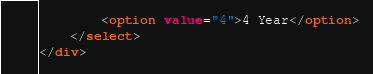Convert code to text. <code><loc_0><loc_0><loc_500><loc_500><_HTML_>        <option value="4">4 Year</option>
    </select>
</div></code> 